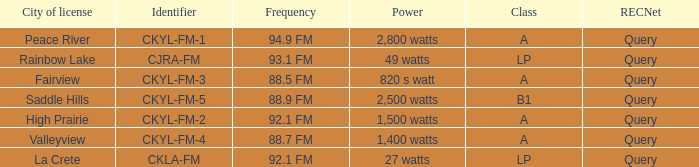What is the city of license that has a 1,400 watts power Valleyview. 